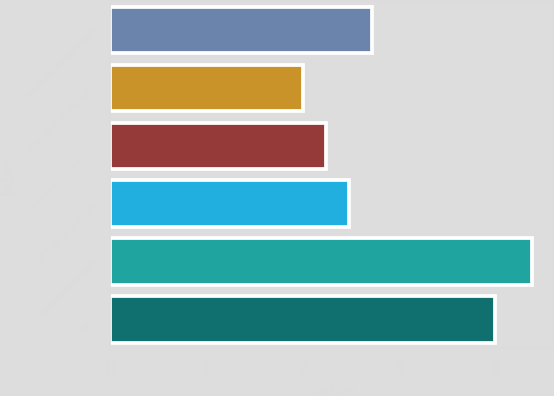Convert chart to OTSL. <chart><loc_0><loc_0><loc_500><loc_500><bar_chart><fcel>Commercial mortgage loans<fcel>Agricultural property loans<fcel>Residential property loans<fcel>Other collateralized loans<fcel>Uncollateralized loans<fcel>Total<nl><fcel>2.72<fcel>2<fcel>2.24<fcel>2.48<fcel>4.39<fcel>4<nl></chart> 